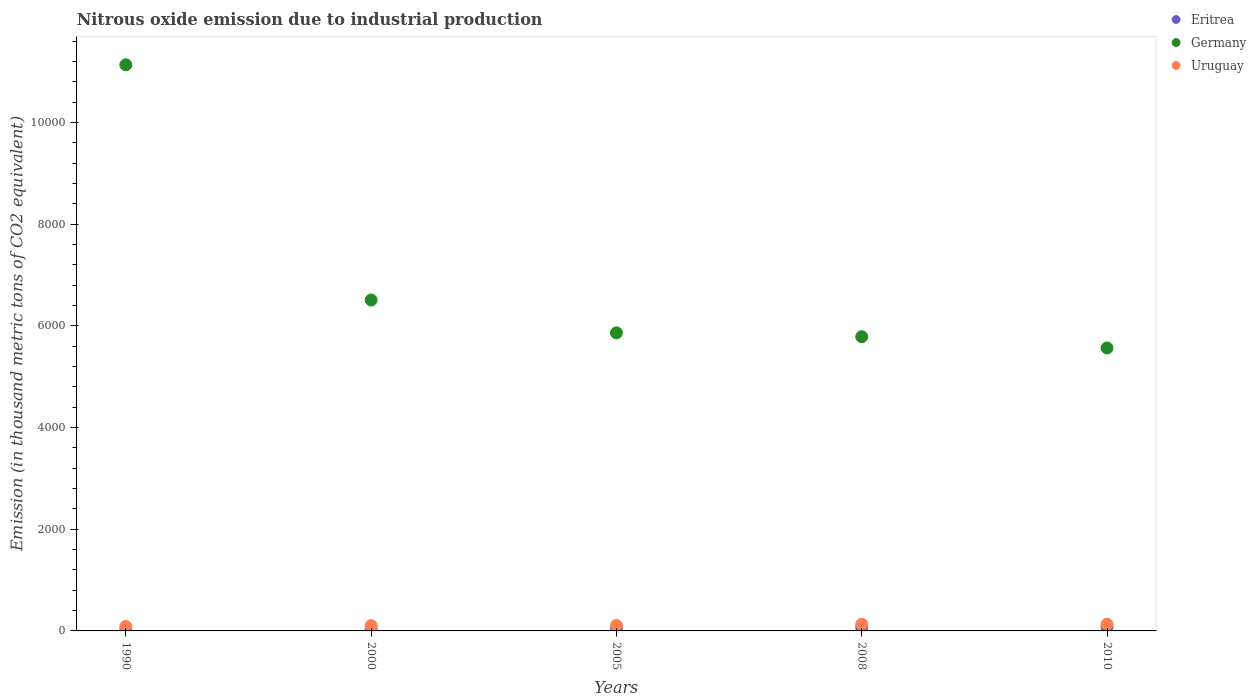How many different coloured dotlines are there?
Offer a very short reply. 3. What is the amount of nitrous oxide emitted in Germany in 2008?
Your answer should be very brief. 5785.7. Across all years, what is the maximum amount of nitrous oxide emitted in Eritrea?
Keep it short and to the point. 73.9. Across all years, what is the minimum amount of nitrous oxide emitted in Germany?
Provide a short and direct response. 5564. In which year was the amount of nitrous oxide emitted in Germany maximum?
Provide a succinct answer. 1990. In which year was the amount of nitrous oxide emitted in Uruguay minimum?
Your response must be concise. 1990. What is the total amount of nitrous oxide emitted in Uruguay in the graph?
Keep it short and to the point. 561.2. What is the difference between the amount of nitrous oxide emitted in Germany in 2000 and that in 2008?
Ensure brevity in your answer.  721.3. What is the average amount of nitrous oxide emitted in Uruguay per year?
Provide a short and direct response. 112.24. In the year 2000, what is the difference between the amount of nitrous oxide emitted in Eritrea and amount of nitrous oxide emitted in Germany?
Make the answer very short. -6461.6. In how many years, is the amount of nitrous oxide emitted in Eritrea greater than 400 thousand metric tons?
Keep it short and to the point. 0. What is the ratio of the amount of nitrous oxide emitted in Eritrea in 1990 to that in 2000?
Offer a terse response. 0.69. What is the difference between the highest and the second highest amount of nitrous oxide emitted in Eritrea?
Ensure brevity in your answer.  4.2. What is the difference between the highest and the lowest amount of nitrous oxide emitted in Eritrea?
Provide a succinct answer. 42.6. Are the values on the major ticks of Y-axis written in scientific E-notation?
Ensure brevity in your answer.  No. Where does the legend appear in the graph?
Keep it short and to the point. Top right. How many legend labels are there?
Your answer should be very brief. 3. How are the legend labels stacked?
Offer a terse response. Vertical. What is the title of the graph?
Offer a very short reply. Nitrous oxide emission due to industrial production. What is the label or title of the X-axis?
Your response must be concise. Years. What is the label or title of the Y-axis?
Your answer should be very brief. Emission (in thousand metric tons of CO2 equivalent). What is the Emission (in thousand metric tons of CO2 equivalent) in Eritrea in 1990?
Your answer should be very brief. 31.3. What is the Emission (in thousand metric tons of CO2 equivalent) of Germany in 1990?
Ensure brevity in your answer.  1.11e+04. What is the Emission (in thousand metric tons of CO2 equivalent) in Uruguay in 1990?
Provide a succinct answer. 88.8. What is the Emission (in thousand metric tons of CO2 equivalent) in Eritrea in 2000?
Your answer should be compact. 45.4. What is the Emission (in thousand metric tons of CO2 equivalent) of Germany in 2000?
Offer a very short reply. 6507. What is the Emission (in thousand metric tons of CO2 equivalent) in Uruguay in 2000?
Ensure brevity in your answer.  103.4. What is the Emission (in thousand metric tons of CO2 equivalent) of Eritrea in 2005?
Ensure brevity in your answer.  49.1. What is the Emission (in thousand metric tons of CO2 equivalent) in Germany in 2005?
Your response must be concise. 5860.9. What is the Emission (in thousand metric tons of CO2 equivalent) of Uruguay in 2005?
Keep it short and to the point. 106.6. What is the Emission (in thousand metric tons of CO2 equivalent) in Eritrea in 2008?
Your answer should be very brief. 69.7. What is the Emission (in thousand metric tons of CO2 equivalent) in Germany in 2008?
Keep it short and to the point. 5785.7. What is the Emission (in thousand metric tons of CO2 equivalent) in Uruguay in 2008?
Your answer should be compact. 129.9. What is the Emission (in thousand metric tons of CO2 equivalent) of Eritrea in 2010?
Your answer should be compact. 73.9. What is the Emission (in thousand metric tons of CO2 equivalent) of Germany in 2010?
Provide a succinct answer. 5564. What is the Emission (in thousand metric tons of CO2 equivalent) of Uruguay in 2010?
Your response must be concise. 132.5. Across all years, what is the maximum Emission (in thousand metric tons of CO2 equivalent) of Eritrea?
Make the answer very short. 73.9. Across all years, what is the maximum Emission (in thousand metric tons of CO2 equivalent) in Germany?
Your answer should be very brief. 1.11e+04. Across all years, what is the maximum Emission (in thousand metric tons of CO2 equivalent) of Uruguay?
Your response must be concise. 132.5. Across all years, what is the minimum Emission (in thousand metric tons of CO2 equivalent) of Eritrea?
Your response must be concise. 31.3. Across all years, what is the minimum Emission (in thousand metric tons of CO2 equivalent) in Germany?
Provide a short and direct response. 5564. Across all years, what is the minimum Emission (in thousand metric tons of CO2 equivalent) of Uruguay?
Provide a short and direct response. 88.8. What is the total Emission (in thousand metric tons of CO2 equivalent) of Eritrea in the graph?
Make the answer very short. 269.4. What is the total Emission (in thousand metric tons of CO2 equivalent) in Germany in the graph?
Offer a very short reply. 3.48e+04. What is the total Emission (in thousand metric tons of CO2 equivalent) in Uruguay in the graph?
Your answer should be very brief. 561.2. What is the difference between the Emission (in thousand metric tons of CO2 equivalent) in Eritrea in 1990 and that in 2000?
Offer a terse response. -14.1. What is the difference between the Emission (in thousand metric tons of CO2 equivalent) of Germany in 1990 and that in 2000?
Offer a very short reply. 4625.2. What is the difference between the Emission (in thousand metric tons of CO2 equivalent) in Uruguay in 1990 and that in 2000?
Offer a terse response. -14.6. What is the difference between the Emission (in thousand metric tons of CO2 equivalent) of Eritrea in 1990 and that in 2005?
Provide a succinct answer. -17.8. What is the difference between the Emission (in thousand metric tons of CO2 equivalent) in Germany in 1990 and that in 2005?
Provide a succinct answer. 5271.3. What is the difference between the Emission (in thousand metric tons of CO2 equivalent) of Uruguay in 1990 and that in 2005?
Give a very brief answer. -17.8. What is the difference between the Emission (in thousand metric tons of CO2 equivalent) of Eritrea in 1990 and that in 2008?
Keep it short and to the point. -38.4. What is the difference between the Emission (in thousand metric tons of CO2 equivalent) in Germany in 1990 and that in 2008?
Your answer should be very brief. 5346.5. What is the difference between the Emission (in thousand metric tons of CO2 equivalent) in Uruguay in 1990 and that in 2008?
Provide a short and direct response. -41.1. What is the difference between the Emission (in thousand metric tons of CO2 equivalent) of Eritrea in 1990 and that in 2010?
Your answer should be compact. -42.6. What is the difference between the Emission (in thousand metric tons of CO2 equivalent) in Germany in 1990 and that in 2010?
Make the answer very short. 5568.2. What is the difference between the Emission (in thousand metric tons of CO2 equivalent) in Uruguay in 1990 and that in 2010?
Provide a short and direct response. -43.7. What is the difference between the Emission (in thousand metric tons of CO2 equivalent) of Germany in 2000 and that in 2005?
Make the answer very short. 646.1. What is the difference between the Emission (in thousand metric tons of CO2 equivalent) of Eritrea in 2000 and that in 2008?
Provide a succinct answer. -24.3. What is the difference between the Emission (in thousand metric tons of CO2 equivalent) in Germany in 2000 and that in 2008?
Your response must be concise. 721.3. What is the difference between the Emission (in thousand metric tons of CO2 equivalent) of Uruguay in 2000 and that in 2008?
Your answer should be compact. -26.5. What is the difference between the Emission (in thousand metric tons of CO2 equivalent) of Eritrea in 2000 and that in 2010?
Give a very brief answer. -28.5. What is the difference between the Emission (in thousand metric tons of CO2 equivalent) of Germany in 2000 and that in 2010?
Keep it short and to the point. 943. What is the difference between the Emission (in thousand metric tons of CO2 equivalent) of Uruguay in 2000 and that in 2010?
Ensure brevity in your answer.  -29.1. What is the difference between the Emission (in thousand metric tons of CO2 equivalent) in Eritrea in 2005 and that in 2008?
Your answer should be very brief. -20.6. What is the difference between the Emission (in thousand metric tons of CO2 equivalent) in Germany in 2005 and that in 2008?
Ensure brevity in your answer.  75.2. What is the difference between the Emission (in thousand metric tons of CO2 equivalent) in Uruguay in 2005 and that in 2008?
Make the answer very short. -23.3. What is the difference between the Emission (in thousand metric tons of CO2 equivalent) of Eritrea in 2005 and that in 2010?
Provide a short and direct response. -24.8. What is the difference between the Emission (in thousand metric tons of CO2 equivalent) in Germany in 2005 and that in 2010?
Your response must be concise. 296.9. What is the difference between the Emission (in thousand metric tons of CO2 equivalent) of Uruguay in 2005 and that in 2010?
Offer a very short reply. -25.9. What is the difference between the Emission (in thousand metric tons of CO2 equivalent) of Eritrea in 2008 and that in 2010?
Provide a succinct answer. -4.2. What is the difference between the Emission (in thousand metric tons of CO2 equivalent) of Germany in 2008 and that in 2010?
Ensure brevity in your answer.  221.7. What is the difference between the Emission (in thousand metric tons of CO2 equivalent) of Uruguay in 2008 and that in 2010?
Provide a succinct answer. -2.6. What is the difference between the Emission (in thousand metric tons of CO2 equivalent) of Eritrea in 1990 and the Emission (in thousand metric tons of CO2 equivalent) of Germany in 2000?
Your answer should be very brief. -6475.7. What is the difference between the Emission (in thousand metric tons of CO2 equivalent) of Eritrea in 1990 and the Emission (in thousand metric tons of CO2 equivalent) of Uruguay in 2000?
Provide a succinct answer. -72.1. What is the difference between the Emission (in thousand metric tons of CO2 equivalent) in Germany in 1990 and the Emission (in thousand metric tons of CO2 equivalent) in Uruguay in 2000?
Offer a terse response. 1.10e+04. What is the difference between the Emission (in thousand metric tons of CO2 equivalent) in Eritrea in 1990 and the Emission (in thousand metric tons of CO2 equivalent) in Germany in 2005?
Provide a succinct answer. -5829.6. What is the difference between the Emission (in thousand metric tons of CO2 equivalent) in Eritrea in 1990 and the Emission (in thousand metric tons of CO2 equivalent) in Uruguay in 2005?
Offer a very short reply. -75.3. What is the difference between the Emission (in thousand metric tons of CO2 equivalent) of Germany in 1990 and the Emission (in thousand metric tons of CO2 equivalent) of Uruguay in 2005?
Provide a short and direct response. 1.10e+04. What is the difference between the Emission (in thousand metric tons of CO2 equivalent) in Eritrea in 1990 and the Emission (in thousand metric tons of CO2 equivalent) in Germany in 2008?
Your answer should be very brief. -5754.4. What is the difference between the Emission (in thousand metric tons of CO2 equivalent) of Eritrea in 1990 and the Emission (in thousand metric tons of CO2 equivalent) of Uruguay in 2008?
Your answer should be very brief. -98.6. What is the difference between the Emission (in thousand metric tons of CO2 equivalent) in Germany in 1990 and the Emission (in thousand metric tons of CO2 equivalent) in Uruguay in 2008?
Offer a terse response. 1.10e+04. What is the difference between the Emission (in thousand metric tons of CO2 equivalent) of Eritrea in 1990 and the Emission (in thousand metric tons of CO2 equivalent) of Germany in 2010?
Make the answer very short. -5532.7. What is the difference between the Emission (in thousand metric tons of CO2 equivalent) in Eritrea in 1990 and the Emission (in thousand metric tons of CO2 equivalent) in Uruguay in 2010?
Keep it short and to the point. -101.2. What is the difference between the Emission (in thousand metric tons of CO2 equivalent) of Germany in 1990 and the Emission (in thousand metric tons of CO2 equivalent) of Uruguay in 2010?
Provide a succinct answer. 1.10e+04. What is the difference between the Emission (in thousand metric tons of CO2 equivalent) of Eritrea in 2000 and the Emission (in thousand metric tons of CO2 equivalent) of Germany in 2005?
Make the answer very short. -5815.5. What is the difference between the Emission (in thousand metric tons of CO2 equivalent) in Eritrea in 2000 and the Emission (in thousand metric tons of CO2 equivalent) in Uruguay in 2005?
Provide a succinct answer. -61.2. What is the difference between the Emission (in thousand metric tons of CO2 equivalent) of Germany in 2000 and the Emission (in thousand metric tons of CO2 equivalent) of Uruguay in 2005?
Keep it short and to the point. 6400.4. What is the difference between the Emission (in thousand metric tons of CO2 equivalent) of Eritrea in 2000 and the Emission (in thousand metric tons of CO2 equivalent) of Germany in 2008?
Provide a short and direct response. -5740.3. What is the difference between the Emission (in thousand metric tons of CO2 equivalent) of Eritrea in 2000 and the Emission (in thousand metric tons of CO2 equivalent) of Uruguay in 2008?
Offer a very short reply. -84.5. What is the difference between the Emission (in thousand metric tons of CO2 equivalent) of Germany in 2000 and the Emission (in thousand metric tons of CO2 equivalent) of Uruguay in 2008?
Make the answer very short. 6377.1. What is the difference between the Emission (in thousand metric tons of CO2 equivalent) of Eritrea in 2000 and the Emission (in thousand metric tons of CO2 equivalent) of Germany in 2010?
Your response must be concise. -5518.6. What is the difference between the Emission (in thousand metric tons of CO2 equivalent) of Eritrea in 2000 and the Emission (in thousand metric tons of CO2 equivalent) of Uruguay in 2010?
Your answer should be compact. -87.1. What is the difference between the Emission (in thousand metric tons of CO2 equivalent) of Germany in 2000 and the Emission (in thousand metric tons of CO2 equivalent) of Uruguay in 2010?
Keep it short and to the point. 6374.5. What is the difference between the Emission (in thousand metric tons of CO2 equivalent) of Eritrea in 2005 and the Emission (in thousand metric tons of CO2 equivalent) of Germany in 2008?
Provide a succinct answer. -5736.6. What is the difference between the Emission (in thousand metric tons of CO2 equivalent) in Eritrea in 2005 and the Emission (in thousand metric tons of CO2 equivalent) in Uruguay in 2008?
Keep it short and to the point. -80.8. What is the difference between the Emission (in thousand metric tons of CO2 equivalent) in Germany in 2005 and the Emission (in thousand metric tons of CO2 equivalent) in Uruguay in 2008?
Your response must be concise. 5731. What is the difference between the Emission (in thousand metric tons of CO2 equivalent) in Eritrea in 2005 and the Emission (in thousand metric tons of CO2 equivalent) in Germany in 2010?
Your response must be concise. -5514.9. What is the difference between the Emission (in thousand metric tons of CO2 equivalent) in Eritrea in 2005 and the Emission (in thousand metric tons of CO2 equivalent) in Uruguay in 2010?
Keep it short and to the point. -83.4. What is the difference between the Emission (in thousand metric tons of CO2 equivalent) of Germany in 2005 and the Emission (in thousand metric tons of CO2 equivalent) of Uruguay in 2010?
Make the answer very short. 5728.4. What is the difference between the Emission (in thousand metric tons of CO2 equivalent) of Eritrea in 2008 and the Emission (in thousand metric tons of CO2 equivalent) of Germany in 2010?
Offer a very short reply. -5494.3. What is the difference between the Emission (in thousand metric tons of CO2 equivalent) of Eritrea in 2008 and the Emission (in thousand metric tons of CO2 equivalent) of Uruguay in 2010?
Provide a short and direct response. -62.8. What is the difference between the Emission (in thousand metric tons of CO2 equivalent) of Germany in 2008 and the Emission (in thousand metric tons of CO2 equivalent) of Uruguay in 2010?
Your answer should be very brief. 5653.2. What is the average Emission (in thousand metric tons of CO2 equivalent) of Eritrea per year?
Your response must be concise. 53.88. What is the average Emission (in thousand metric tons of CO2 equivalent) of Germany per year?
Your answer should be compact. 6969.96. What is the average Emission (in thousand metric tons of CO2 equivalent) of Uruguay per year?
Give a very brief answer. 112.24. In the year 1990, what is the difference between the Emission (in thousand metric tons of CO2 equivalent) of Eritrea and Emission (in thousand metric tons of CO2 equivalent) of Germany?
Keep it short and to the point. -1.11e+04. In the year 1990, what is the difference between the Emission (in thousand metric tons of CO2 equivalent) of Eritrea and Emission (in thousand metric tons of CO2 equivalent) of Uruguay?
Keep it short and to the point. -57.5. In the year 1990, what is the difference between the Emission (in thousand metric tons of CO2 equivalent) in Germany and Emission (in thousand metric tons of CO2 equivalent) in Uruguay?
Your response must be concise. 1.10e+04. In the year 2000, what is the difference between the Emission (in thousand metric tons of CO2 equivalent) in Eritrea and Emission (in thousand metric tons of CO2 equivalent) in Germany?
Offer a terse response. -6461.6. In the year 2000, what is the difference between the Emission (in thousand metric tons of CO2 equivalent) of Eritrea and Emission (in thousand metric tons of CO2 equivalent) of Uruguay?
Offer a terse response. -58. In the year 2000, what is the difference between the Emission (in thousand metric tons of CO2 equivalent) in Germany and Emission (in thousand metric tons of CO2 equivalent) in Uruguay?
Your answer should be very brief. 6403.6. In the year 2005, what is the difference between the Emission (in thousand metric tons of CO2 equivalent) in Eritrea and Emission (in thousand metric tons of CO2 equivalent) in Germany?
Give a very brief answer. -5811.8. In the year 2005, what is the difference between the Emission (in thousand metric tons of CO2 equivalent) of Eritrea and Emission (in thousand metric tons of CO2 equivalent) of Uruguay?
Make the answer very short. -57.5. In the year 2005, what is the difference between the Emission (in thousand metric tons of CO2 equivalent) in Germany and Emission (in thousand metric tons of CO2 equivalent) in Uruguay?
Provide a succinct answer. 5754.3. In the year 2008, what is the difference between the Emission (in thousand metric tons of CO2 equivalent) in Eritrea and Emission (in thousand metric tons of CO2 equivalent) in Germany?
Offer a terse response. -5716. In the year 2008, what is the difference between the Emission (in thousand metric tons of CO2 equivalent) of Eritrea and Emission (in thousand metric tons of CO2 equivalent) of Uruguay?
Provide a succinct answer. -60.2. In the year 2008, what is the difference between the Emission (in thousand metric tons of CO2 equivalent) of Germany and Emission (in thousand metric tons of CO2 equivalent) of Uruguay?
Offer a very short reply. 5655.8. In the year 2010, what is the difference between the Emission (in thousand metric tons of CO2 equivalent) of Eritrea and Emission (in thousand metric tons of CO2 equivalent) of Germany?
Offer a very short reply. -5490.1. In the year 2010, what is the difference between the Emission (in thousand metric tons of CO2 equivalent) of Eritrea and Emission (in thousand metric tons of CO2 equivalent) of Uruguay?
Offer a terse response. -58.6. In the year 2010, what is the difference between the Emission (in thousand metric tons of CO2 equivalent) of Germany and Emission (in thousand metric tons of CO2 equivalent) of Uruguay?
Offer a terse response. 5431.5. What is the ratio of the Emission (in thousand metric tons of CO2 equivalent) in Eritrea in 1990 to that in 2000?
Provide a succinct answer. 0.69. What is the ratio of the Emission (in thousand metric tons of CO2 equivalent) in Germany in 1990 to that in 2000?
Your response must be concise. 1.71. What is the ratio of the Emission (in thousand metric tons of CO2 equivalent) in Uruguay in 1990 to that in 2000?
Provide a short and direct response. 0.86. What is the ratio of the Emission (in thousand metric tons of CO2 equivalent) in Eritrea in 1990 to that in 2005?
Keep it short and to the point. 0.64. What is the ratio of the Emission (in thousand metric tons of CO2 equivalent) of Germany in 1990 to that in 2005?
Your answer should be very brief. 1.9. What is the ratio of the Emission (in thousand metric tons of CO2 equivalent) of Uruguay in 1990 to that in 2005?
Your answer should be compact. 0.83. What is the ratio of the Emission (in thousand metric tons of CO2 equivalent) in Eritrea in 1990 to that in 2008?
Ensure brevity in your answer.  0.45. What is the ratio of the Emission (in thousand metric tons of CO2 equivalent) of Germany in 1990 to that in 2008?
Offer a very short reply. 1.92. What is the ratio of the Emission (in thousand metric tons of CO2 equivalent) of Uruguay in 1990 to that in 2008?
Your answer should be very brief. 0.68. What is the ratio of the Emission (in thousand metric tons of CO2 equivalent) of Eritrea in 1990 to that in 2010?
Give a very brief answer. 0.42. What is the ratio of the Emission (in thousand metric tons of CO2 equivalent) in Germany in 1990 to that in 2010?
Make the answer very short. 2. What is the ratio of the Emission (in thousand metric tons of CO2 equivalent) in Uruguay in 1990 to that in 2010?
Make the answer very short. 0.67. What is the ratio of the Emission (in thousand metric tons of CO2 equivalent) of Eritrea in 2000 to that in 2005?
Keep it short and to the point. 0.92. What is the ratio of the Emission (in thousand metric tons of CO2 equivalent) of Germany in 2000 to that in 2005?
Keep it short and to the point. 1.11. What is the ratio of the Emission (in thousand metric tons of CO2 equivalent) in Uruguay in 2000 to that in 2005?
Offer a terse response. 0.97. What is the ratio of the Emission (in thousand metric tons of CO2 equivalent) in Eritrea in 2000 to that in 2008?
Make the answer very short. 0.65. What is the ratio of the Emission (in thousand metric tons of CO2 equivalent) in Germany in 2000 to that in 2008?
Offer a terse response. 1.12. What is the ratio of the Emission (in thousand metric tons of CO2 equivalent) in Uruguay in 2000 to that in 2008?
Your response must be concise. 0.8. What is the ratio of the Emission (in thousand metric tons of CO2 equivalent) in Eritrea in 2000 to that in 2010?
Offer a terse response. 0.61. What is the ratio of the Emission (in thousand metric tons of CO2 equivalent) in Germany in 2000 to that in 2010?
Provide a short and direct response. 1.17. What is the ratio of the Emission (in thousand metric tons of CO2 equivalent) in Uruguay in 2000 to that in 2010?
Make the answer very short. 0.78. What is the ratio of the Emission (in thousand metric tons of CO2 equivalent) in Eritrea in 2005 to that in 2008?
Give a very brief answer. 0.7. What is the ratio of the Emission (in thousand metric tons of CO2 equivalent) in Germany in 2005 to that in 2008?
Your response must be concise. 1.01. What is the ratio of the Emission (in thousand metric tons of CO2 equivalent) of Uruguay in 2005 to that in 2008?
Offer a terse response. 0.82. What is the ratio of the Emission (in thousand metric tons of CO2 equivalent) in Eritrea in 2005 to that in 2010?
Provide a short and direct response. 0.66. What is the ratio of the Emission (in thousand metric tons of CO2 equivalent) in Germany in 2005 to that in 2010?
Provide a succinct answer. 1.05. What is the ratio of the Emission (in thousand metric tons of CO2 equivalent) in Uruguay in 2005 to that in 2010?
Your answer should be compact. 0.8. What is the ratio of the Emission (in thousand metric tons of CO2 equivalent) in Eritrea in 2008 to that in 2010?
Make the answer very short. 0.94. What is the ratio of the Emission (in thousand metric tons of CO2 equivalent) of Germany in 2008 to that in 2010?
Ensure brevity in your answer.  1.04. What is the ratio of the Emission (in thousand metric tons of CO2 equivalent) of Uruguay in 2008 to that in 2010?
Ensure brevity in your answer.  0.98. What is the difference between the highest and the second highest Emission (in thousand metric tons of CO2 equivalent) of Germany?
Your answer should be compact. 4625.2. What is the difference between the highest and the second highest Emission (in thousand metric tons of CO2 equivalent) of Uruguay?
Your answer should be very brief. 2.6. What is the difference between the highest and the lowest Emission (in thousand metric tons of CO2 equivalent) in Eritrea?
Keep it short and to the point. 42.6. What is the difference between the highest and the lowest Emission (in thousand metric tons of CO2 equivalent) of Germany?
Provide a succinct answer. 5568.2. What is the difference between the highest and the lowest Emission (in thousand metric tons of CO2 equivalent) of Uruguay?
Your answer should be compact. 43.7. 